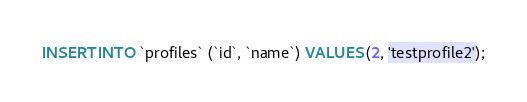Convert code to text. <code><loc_0><loc_0><loc_500><loc_500><_SQL_>INSERT INTO `profiles` (`id`, `name`) VALUES (2, 'testprofile2');</code> 